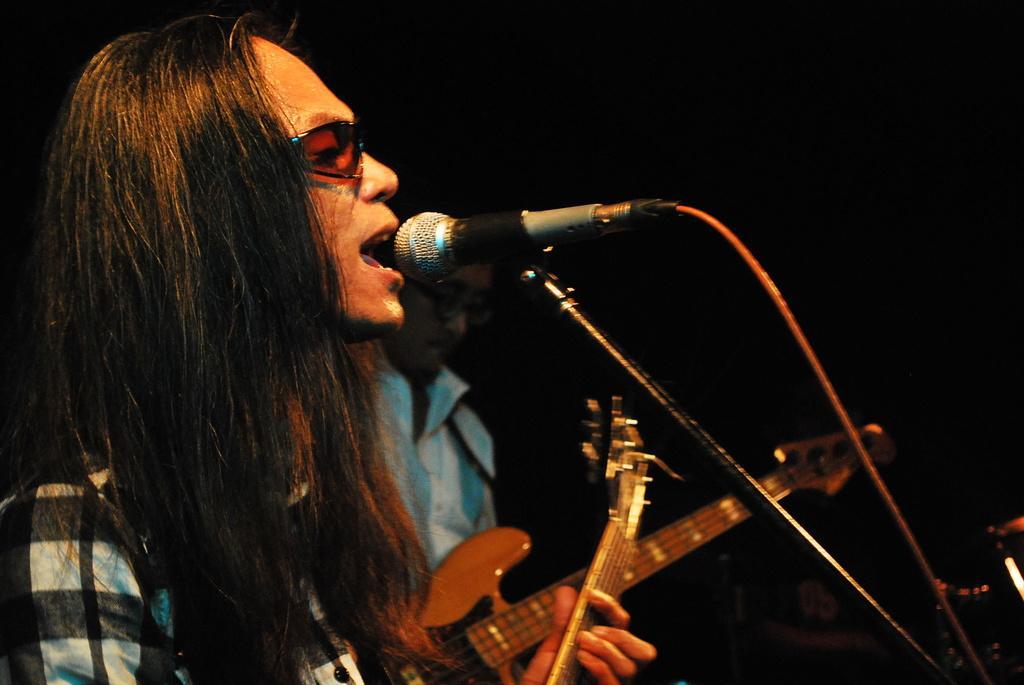In one or two sentences, can you explain what this image depicts? In the picture there are two person standing in front of a microphone and singing there are also playing guitar. 